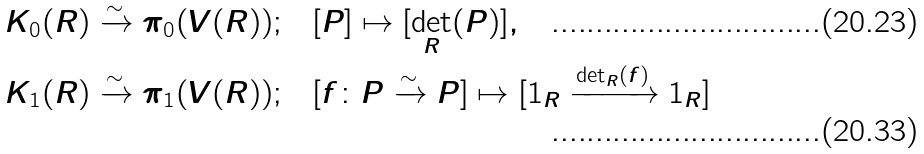<formula> <loc_0><loc_0><loc_500><loc_500>K _ { 0 } ( R ) \xrightarrow { \sim } \pi _ { 0 } ( V ( R ) ) ; & \quad [ P ] \mapsto [ \det _ { R } ( P ) ] , \\ K _ { 1 } ( R ) \xrightarrow { \sim } \pi _ { 1 } ( V ( R ) ) ; & \quad [ f \colon P \xrightarrow { \sim } P ] \mapsto [ 1 _ { R } \xrightarrow { \det _ { R } ( f ) } 1 _ { R } ]</formula> 